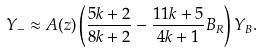<formula> <loc_0><loc_0><loc_500><loc_500>Y _ { - } \approx A ( z ) \left ( \frac { 5 k + 2 } { 8 k + 2 } - \frac { 1 1 k + 5 } { 4 k + 1 } B _ { R } \right ) Y _ { B } .</formula> 